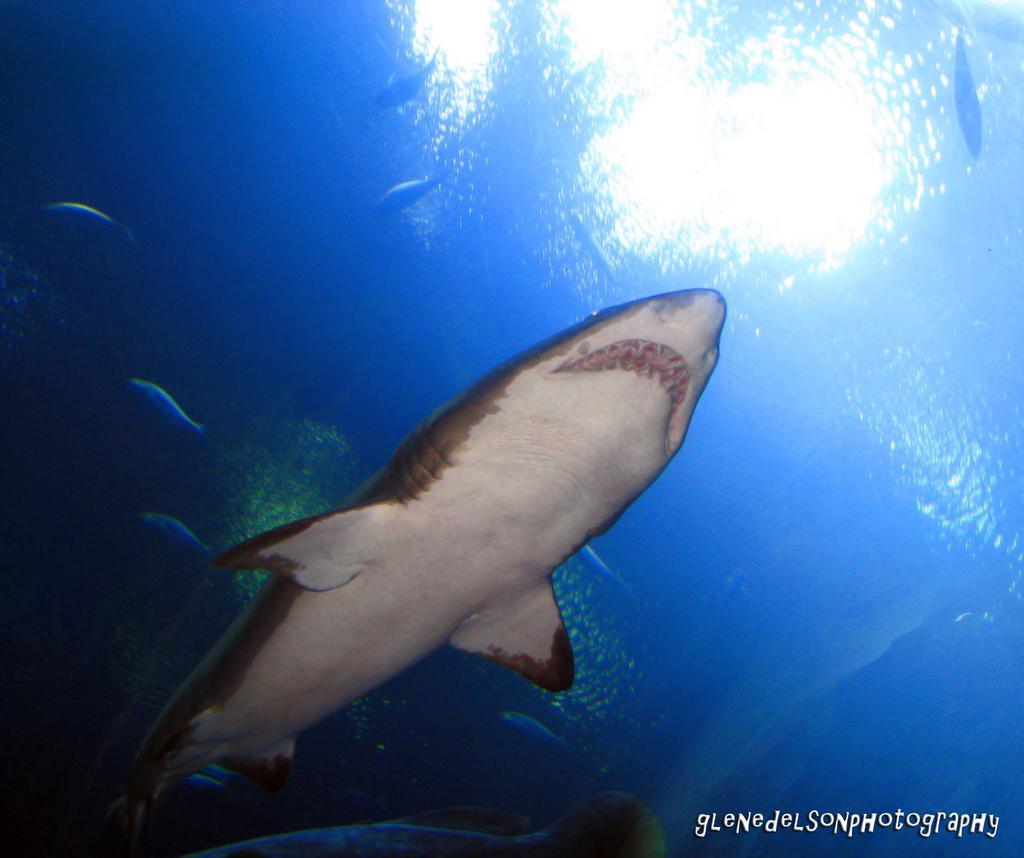Please provide a concise description of this image. In this image, I can see the fishes and a shark moving in the water. This water is blue in color. I can see the watermark on the image. 